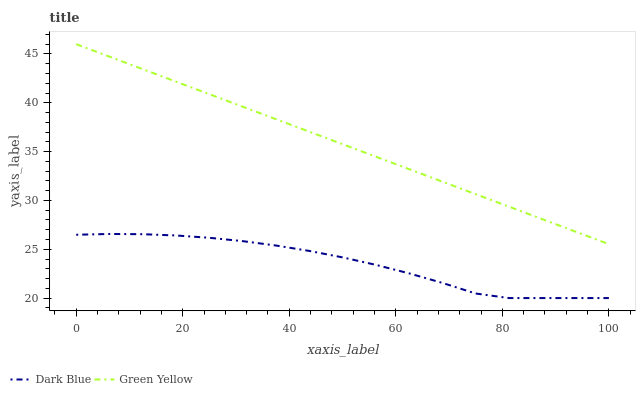Does Dark Blue have the minimum area under the curve?
Answer yes or no. Yes. Does Green Yellow have the maximum area under the curve?
Answer yes or no. Yes. Does Green Yellow have the minimum area under the curve?
Answer yes or no. No. Is Green Yellow the smoothest?
Answer yes or no. Yes. Is Dark Blue the roughest?
Answer yes or no. Yes. Is Green Yellow the roughest?
Answer yes or no. No. Does Dark Blue have the lowest value?
Answer yes or no. Yes. Does Green Yellow have the lowest value?
Answer yes or no. No. Does Green Yellow have the highest value?
Answer yes or no. Yes. Is Dark Blue less than Green Yellow?
Answer yes or no. Yes. Is Green Yellow greater than Dark Blue?
Answer yes or no. Yes. Does Dark Blue intersect Green Yellow?
Answer yes or no. No. 